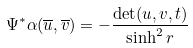Convert formula to latex. <formula><loc_0><loc_0><loc_500><loc_500>\Psi ^ { * } \alpha ( \overline { u } , \overline { v } ) = - \frac { \det ( u , v , t ) } { \sinh ^ { 2 } r }</formula> 